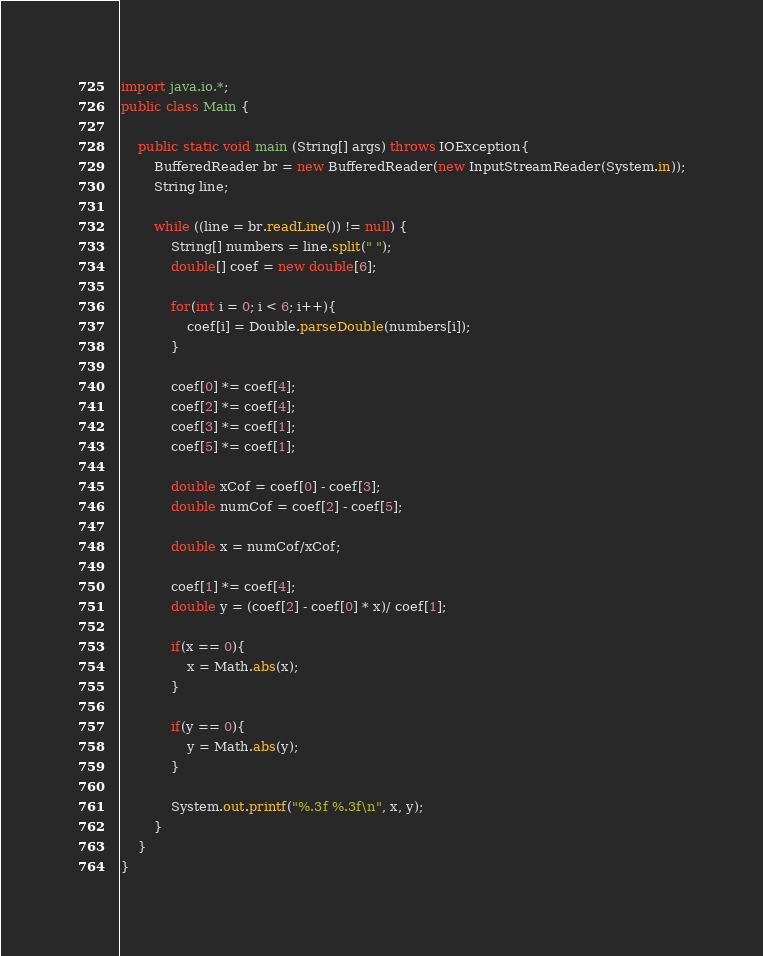<code> <loc_0><loc_0><loc_500><loc_500><_Java_>import java.io.*;
public class Main {

	public static void main (String[] args) throws IOException{
		BufferedReader br = new BufferedReader(new InputStreamReader(System.in));
		String line;
		
		while ((line = br.readLine()) != null) {
			String[] numbers = line.split(" ");
			double[] coef = new double[6];
			
			for(int i = 0; i < 6; i++){
				coef[i] = Double.parseDouble(numbers[i]);
			}
			
			coef[0] *= coef[4];
			coef[2] *= coef[4];
			coef[3] *= coef[1];
			coef[5] *= coef[1];
			
			double xCof = coef[0] - coef[3];
			double numCof = coef[2] - coef[5];
			
			double x = numCof/xCof;
			
			coef[1] *= coef[4];
			double y = (coef[2] - coef[0] * x)/ coef[1];
			
			if(x == 0){
				x = Math.abs(x); 
			}
			
			if(y == 0){
				y = Math.abs(y); 
			}
			
            System.out.printf("%.3f %.3f\n", x, y);
        }
	}
}</code> 